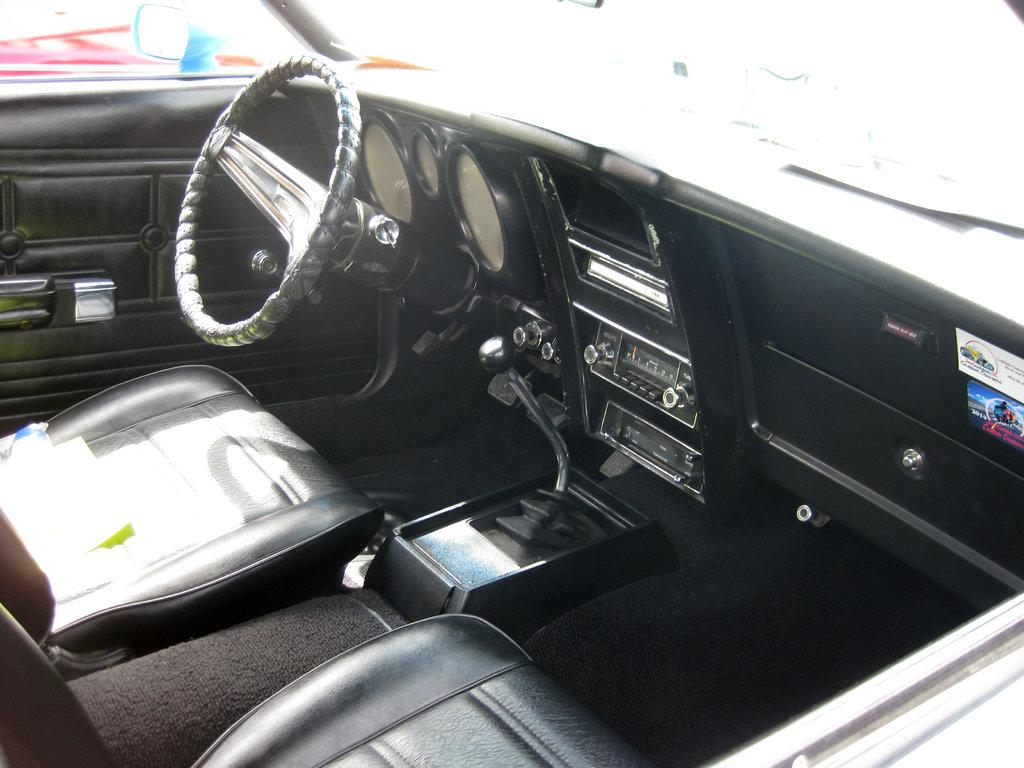What is the perspective of the image? The image appears to be a view from inside a car. What is the main object visible in the image? The steering wheel is visible in the image. What instrument is used to measure the speed of the car? The speedometer is visible in the image. What can be found in a car for passengers to sit on? Seats are present in the image. What other car parts can be seen in the image? Other car parts are visible in the image. Can you tell me what time it is on the clock in the image? There is no clock present in the image. What type of owl can be seen sitting on the dashboard in the image? There is no owl present in the image. 